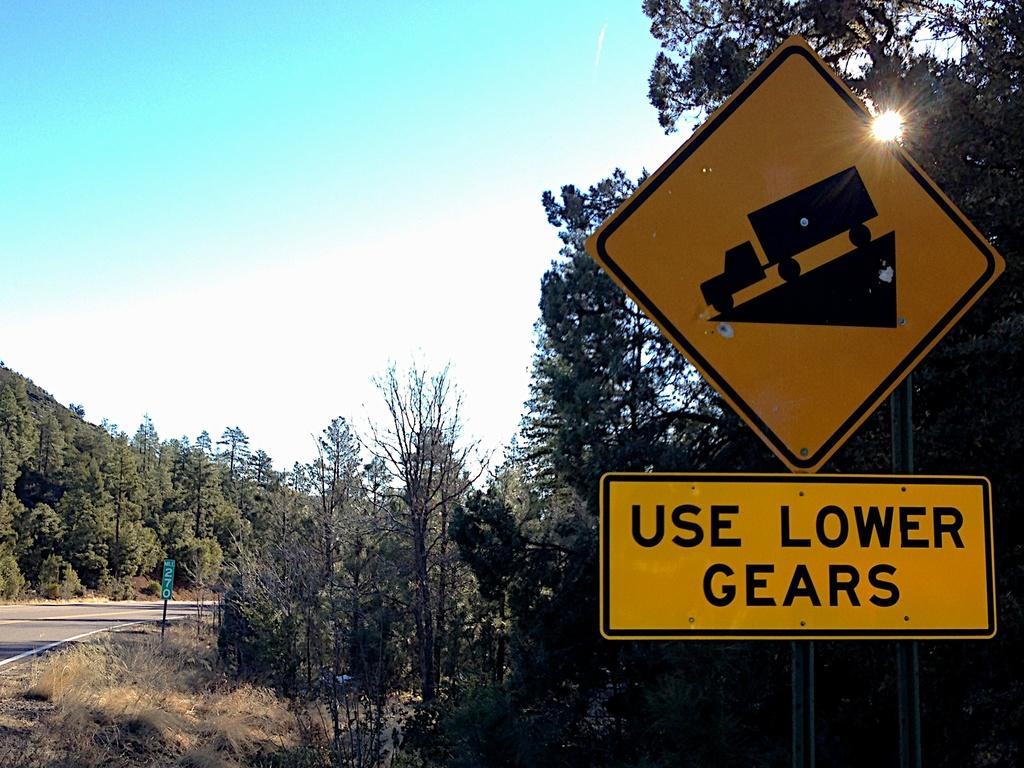<image>
Give a short and clear explanation of the subsequent image. Big, heavy trucks need to use a lower gear to go down the steep grade. 